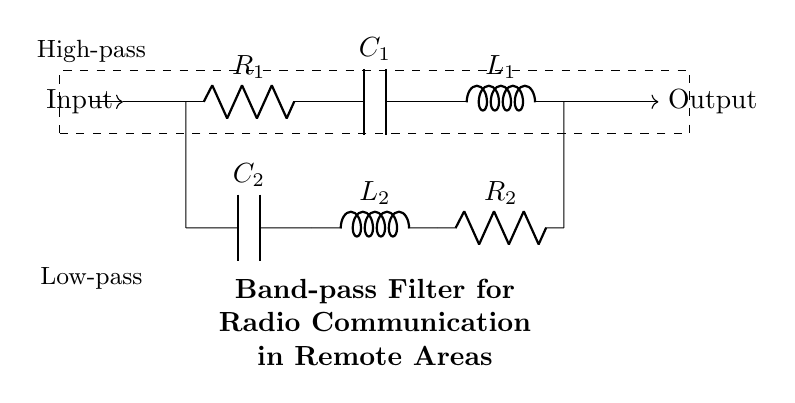What is the type of the first filter stage? The first stage features a capacitor and an inductor alongside a resistor. This configuration signifies a high-pass filter, which allows high-frequency signals to pass while attenuating lower frequencies.
Answer: High-pass What components are present in the low-pass filter? The low-pass filter, positioned in the second stage, contains a capacitor, inductor, and resistor, demonstrating that it permits lower frequencies to pass while blocking higher frequencies.
Answer: Capacitor, inductor, resistor What is the primary function of this circuit? This circuit is designed to filter specific frequencies. With its high-pass and low-pass configurations, it allows a particular range of frequencies to pass—making it suitable for radio communication systems.
Answer: Band-pass filter How many resistors are in the circuit? By inspecting the diagram, I notice there are two resistors, R1 and R2, both placed in their respective filter stages to control the impedance of the circuit.
Answer: Two What is the total number of components in the circuit? Counting each element from the diagram, there are six components in total: two resistors, two capacitors, and two inductors.
Answer: Six What does the output indicate in the circuit? The output arrow indicates that the processed signal is fed out from the circuit. It's the result of the filtering action, where specific frequency signals are allowed to exit while others are rejected.
Answer: Processed signal What is the role of the inductor in the high-pass filter? The inductor works by resisting changes in current, effectively blocking low-frequency signals while allowing higher frequencies to pass through. This characteristic is essential for high-pass filtering behavior.
Answer: Blocks low frequencies 